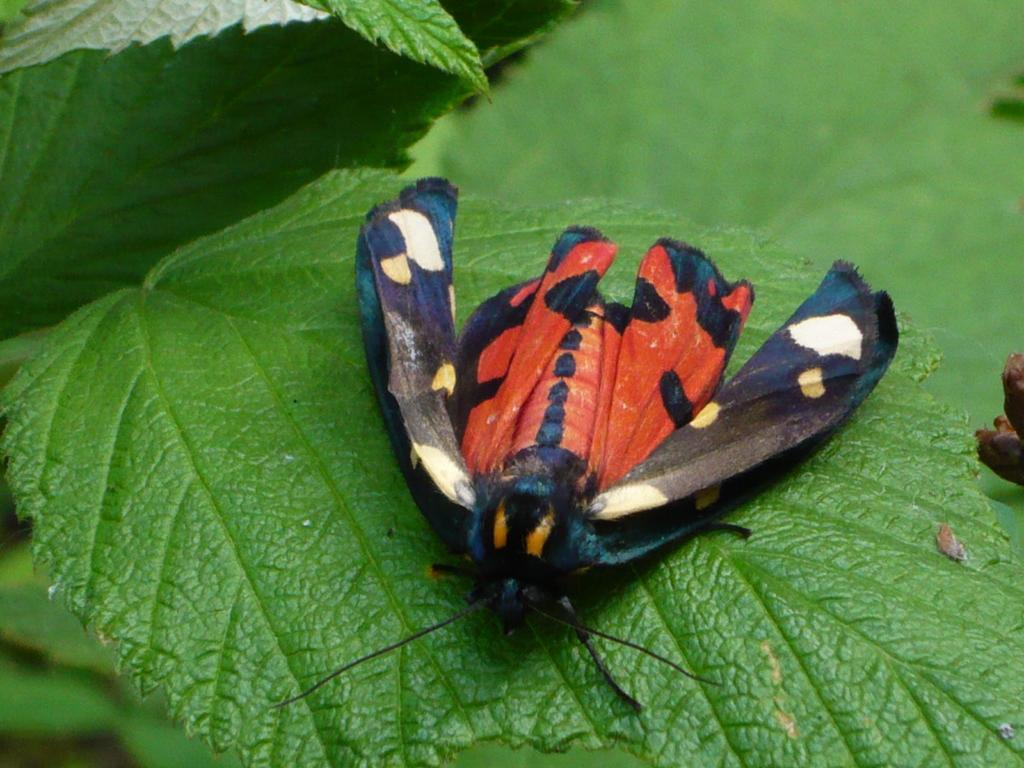What is the main subject of the image? The main subject of the image is a fly on a leaf. Where is the fly located in relation to the leaf? The fly is located in the center of the leaf. What type of sound can be heard coming from the fly in the image? There is no sound coming from the fly in the image, as it is a still photograph. 